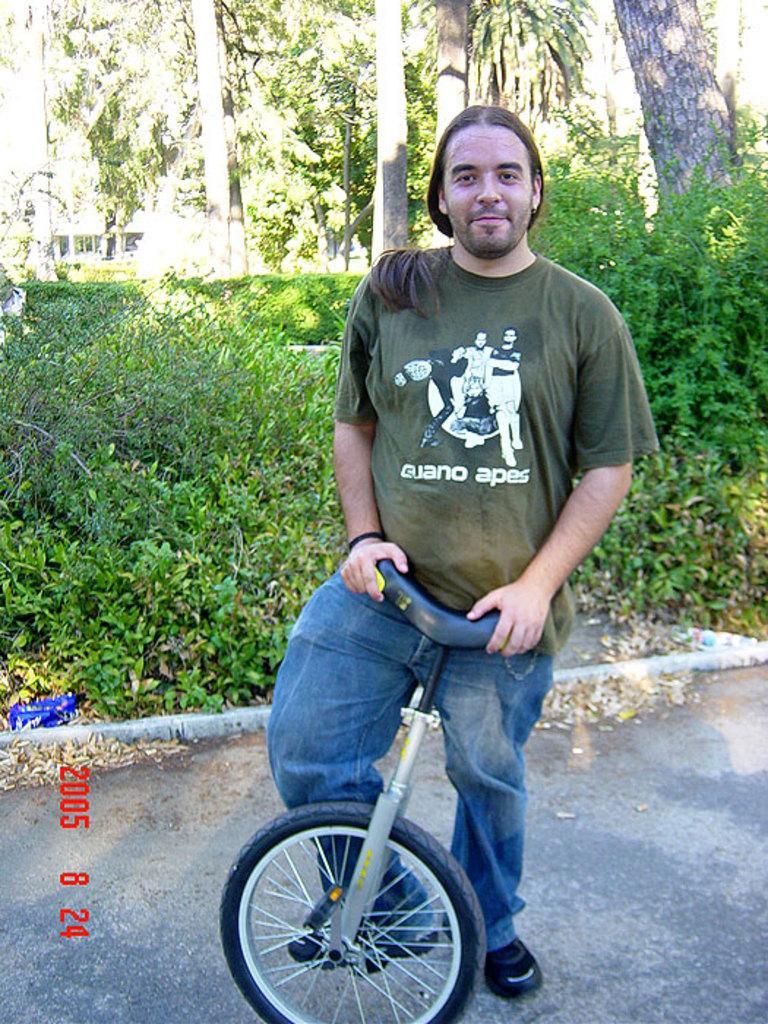Could you give a brief overview of what you see in this image? In the image there is a man standing by holding a cycle and behind him there are plants and trees. 